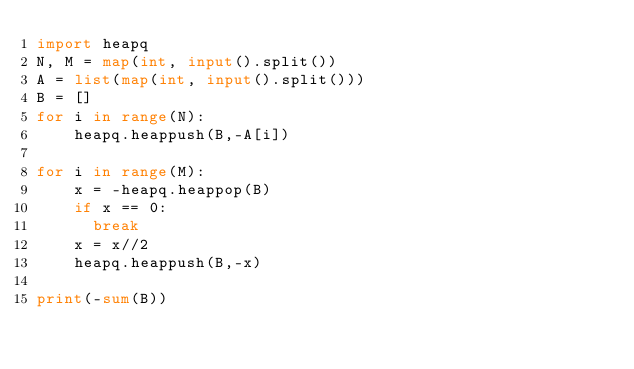<code> <loc_0><loc_0><loc_500><loc_500><_Python_>import heapq
N, M = map(int, input().split())
A = list(map(int, input().split()))
B = []
for i in range(N):
    heapq.heappush(B,-A[i])

for i in range(M):
    x = -heapq.heappop(B)
    if x == 0:
      break
    x = x//2
    heapq.heappush(B,-x)

print(-sum(B))</code> 